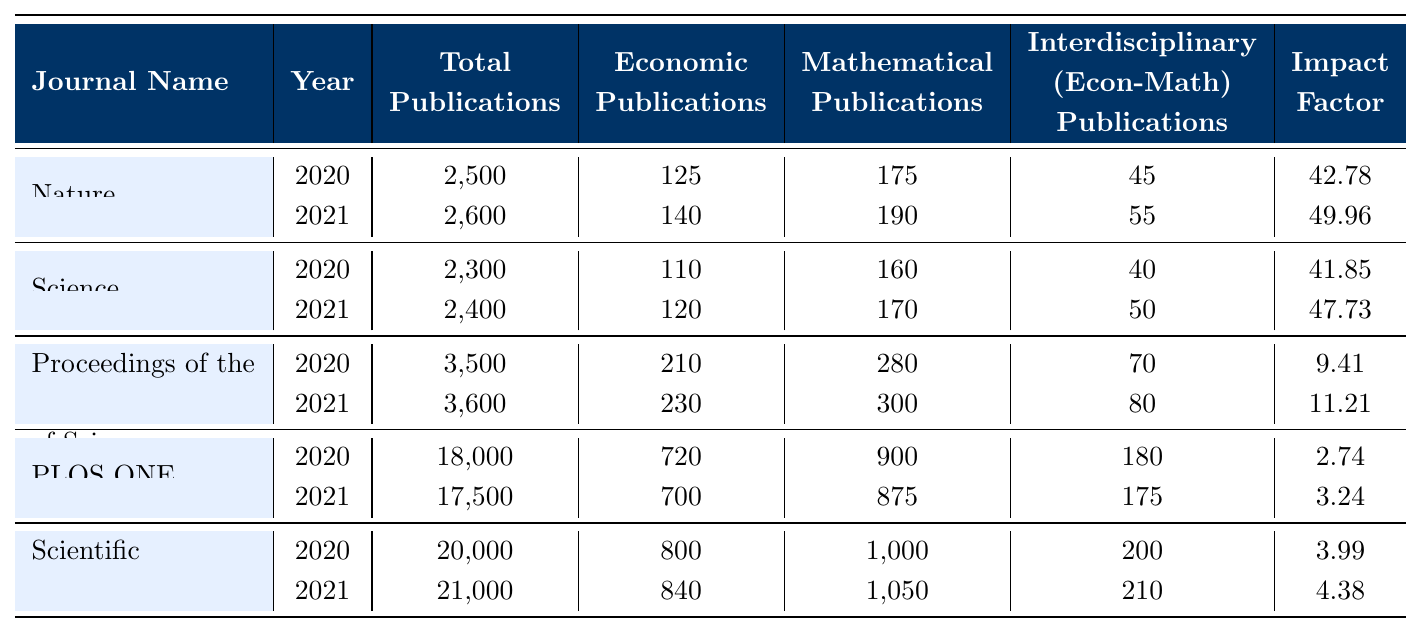What is the total number of publications in 2020 across all journals? To find the total publications in 2020, we add the total publications from each journal for that year: 2500 (Nature) + 2300 (Science) + 3500 (Proceedings of the National Academy of Sciences) + 18000 (PLOS ONE) + 20000 (Scientific Reports) = 2500 + 2300 + 3500 + 18000 + 20000 = 37400
Answer: 37400 How many more economic publications were there in Scientific Reports in 2021 compared to 2020? The number of economic publications in Scientific Reports in 2021 is 840, and in 2020 it was 800. The difference is 840 - 800 = 40.
Answer: 40 Which journal had the highest impact factor in 2021? By comparing the impact factors for 2021: 49.96 (Nature), 47.73 (Science), 11.21 (Proceedings of the National Academy of Sciences), 3.24 (PLOS ONE), and 4.38 (Scientific Reports), Nature has the highest impact factor.
Answer: Nature How many interdisciplinary publications were there in PLOS ONE in 2020 compared to 2021? In 2020, PLOS ONE had 180 interdisciplinary publications, while in 2021 it decreased to 175. The difference is 180 - 175 = 5, indicating a decrease of 5 interdisciplinary publications.
Answer: 5 What is the total number of Mathematical Publications across all journals in 2020? We sum the Mathematical Publications from each journal for 2020: 175 (Nature) + 160 (Science) + 280 (Proceedings of the National Academy of Sciences) + 900 (PLOS ONE) + 1000 (Scientific Reports) = 175 + 160 + 280 + 900 + 1000 = 2515.
Answer: 2515 Is it true that the number of economic publications in 2020 was greater than the number in 2021 for all journals? For Nature: 125 (2020) > 140 (2021) is false; for Science: 110 (2020) > 120 (2021) is false; for Proceedings: 210 (2020) > 230 (2021) is false; for PLOS ONE: 720 (2020) > 700 (2021) is true; for Scientific Reports: 800 (2020) > 840 (2021) is false. Most comparisons are false, so it is not true overall.
Answer: No What is the average impact factor of the journals for the year 2021? The impact factors for 2021 are 49.96, 47.73, 11.21, 3.24, and 4.38. We sum these values: 49.96 + 47.73 + 11.21 + 3.24 + 4.38 = 116.52. Dividing by the number of journals (5), we get 116.52 / 5 = 23.30.
Answer: 23.30 What percentage of total publications in 2021 are interdisciplinary publications in the Proceedings of the National Academy of Sciences? The total publications for the Proceedings of the National Academy of Sciences in 2021 are 3600, and the interdisciplinary publications are 80. The percentage is (80/3600) * 100 = 2.22%.
Answer: 2.22% Which journal experienced the largest growth in total publications from 2020 to 2021? Comparing the total publications: Nature increased from 2500 to 2600 (+100), Science from 2300 to 2400 (+100), Proceedings from 3500 to 3600 (+100), PLOS ONE decreased from 18000 to 17500 (-500), and Scientific Reports increased from 20000 to 21000 (+100). Therefore, the largest growth is 100 for Naurity, Science, and Proceedings.
Answer: 100 